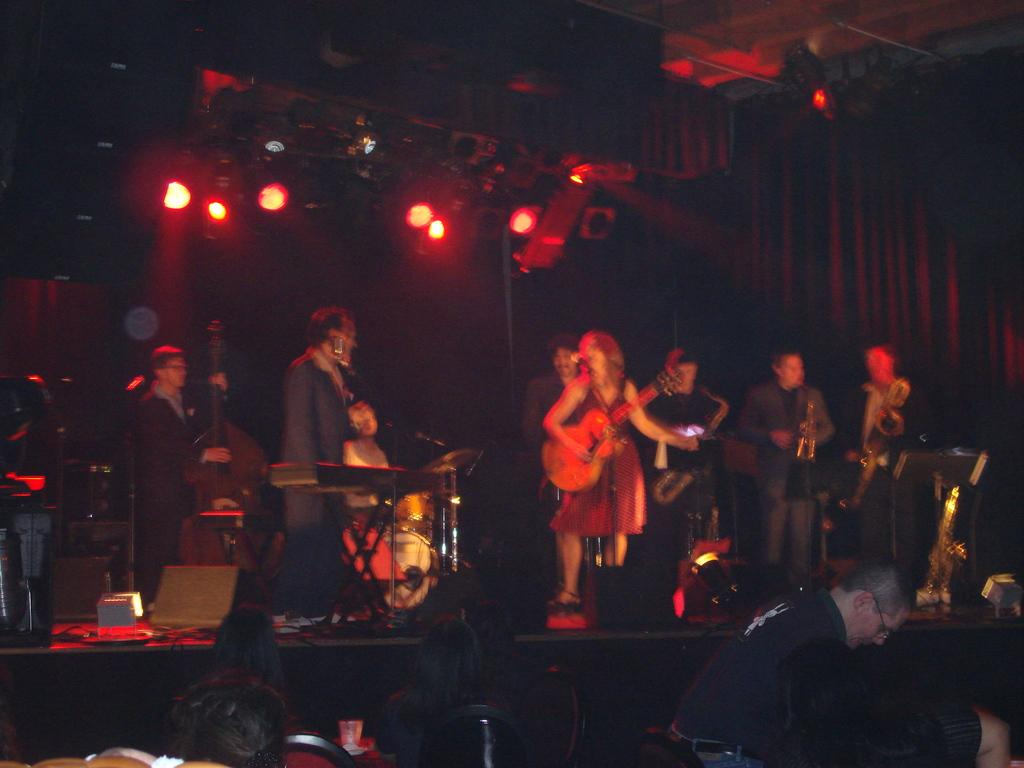How many people are in the group visible in the image? There is a group of people in the image. What are the people in the group doing? The people are playing musical instruments. Can you describe any furniture present in the image? Yes, there is a chair in the image. What type of lighting is present in the image? There are lights in the image. Can you see any friends helping to heal the wound on the wall in the image? There is no mention of a wound or friends helping to heal it in the image. 